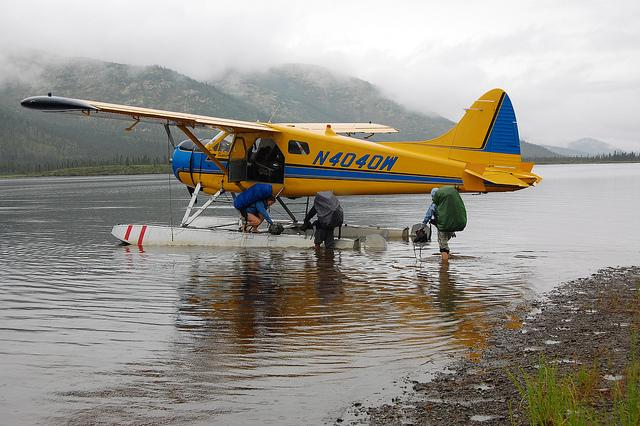What type of plane is being boarded?

Choices:
A) 747
B) jet
C) helicopter
D) pontoon pontoon 